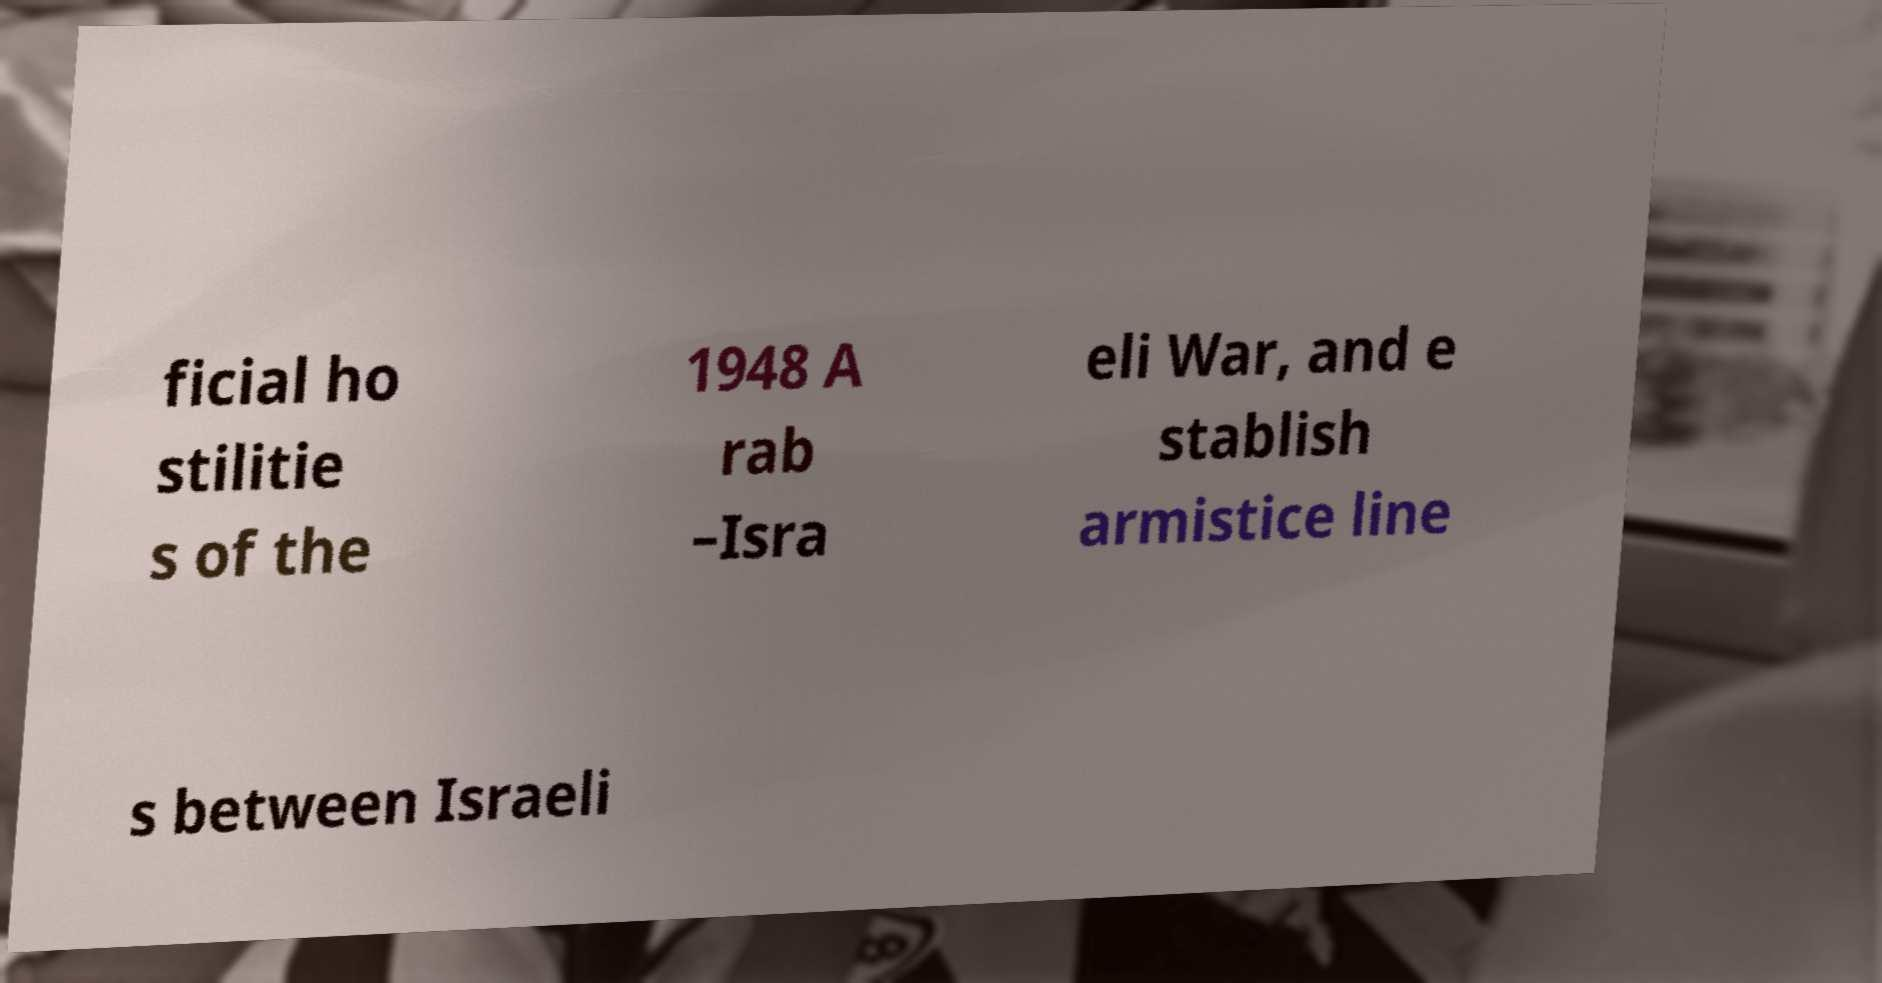Could you assist in decoding the text presented in this image and type it out clearly? ficial ho stilitie s of the 1948 A rab –Isra eli War, and e stablish armistice line s between Israeli 